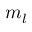<formula> <loc_0><loc_0><loc_500><loc_500>m _ { l }</formula> 